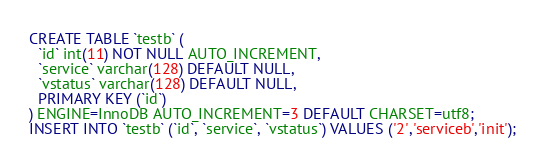<code> <loc_0><loc_0><loc_500><loc_500><_SQL_>
CREATE TABLE `testb` (
  `id` int(11) NOT NULL AUTO_INCREMENT,
  `service` varchar(128) DEFAULT NULL,
  `vstatus` varchar(128) DEFAULT NULL,
  PRIMARY KEY (`id`)
) ENGINE=InnoDB AUTO_INCREMENT=3 DEFAULT CHARSET=utf8;
INSERT INTO `testb` (`id`, `service`, `vstatus`) VALUES ('2','serviceb','init');</code> 